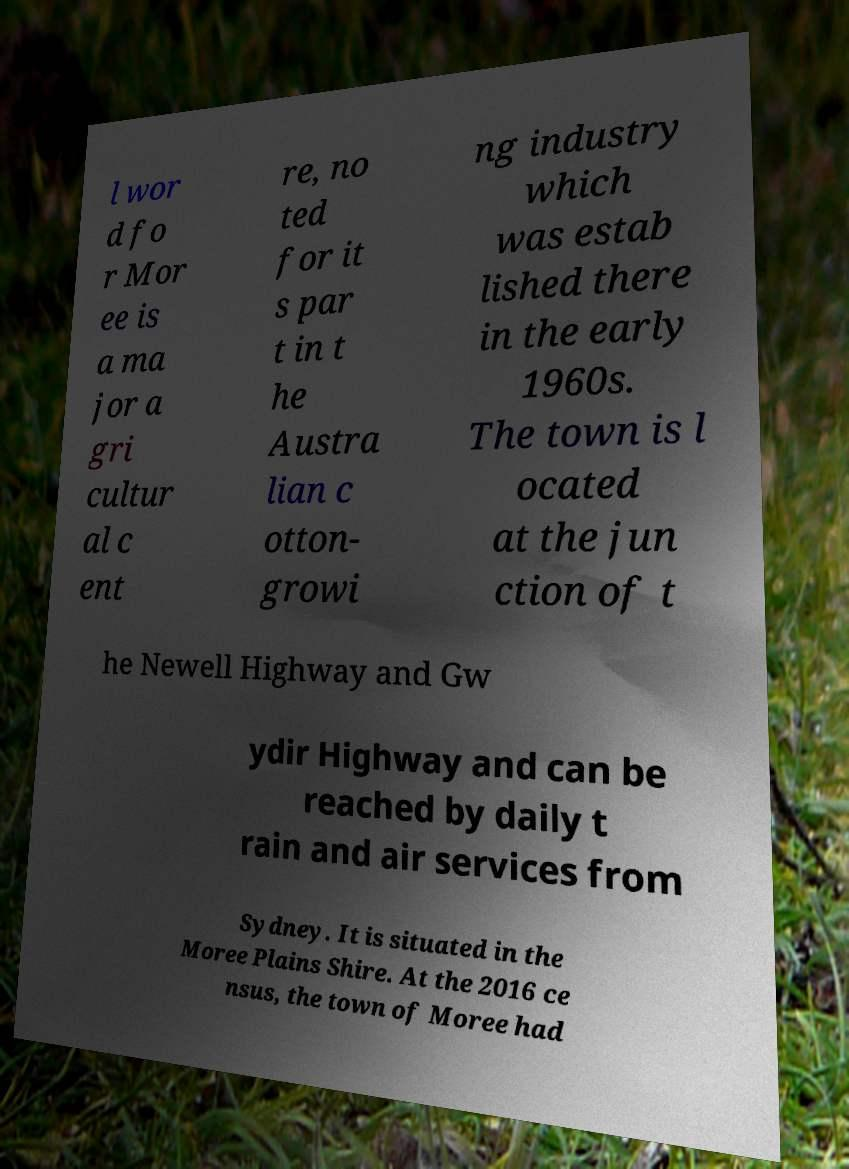Could you assist in decoding the text presented in this image and type it out clearly? l wor d fo r Mor ee is a ma jor a gri cultur al c ent re, no ted for it s par t in t he Austra lian c otton- growi ng industry which was estab lished there in the early 1960s. The town is l ocated at the jun ction of t he Newell Highway and Gw ydir Highway and can be reached by daily t rain and air services from Sydney. It is situated in the Moree Plains Shire. At the 2016 ce nsus, the town of Moree had 